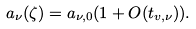<formula> <loc_0><loc_0><loc_500><loc_500>a _ { \nu } ( \zeta ) = a _ { \nu , 0 } ( 1 + O ( t _ { v , \nu } ) ) .</formula> 